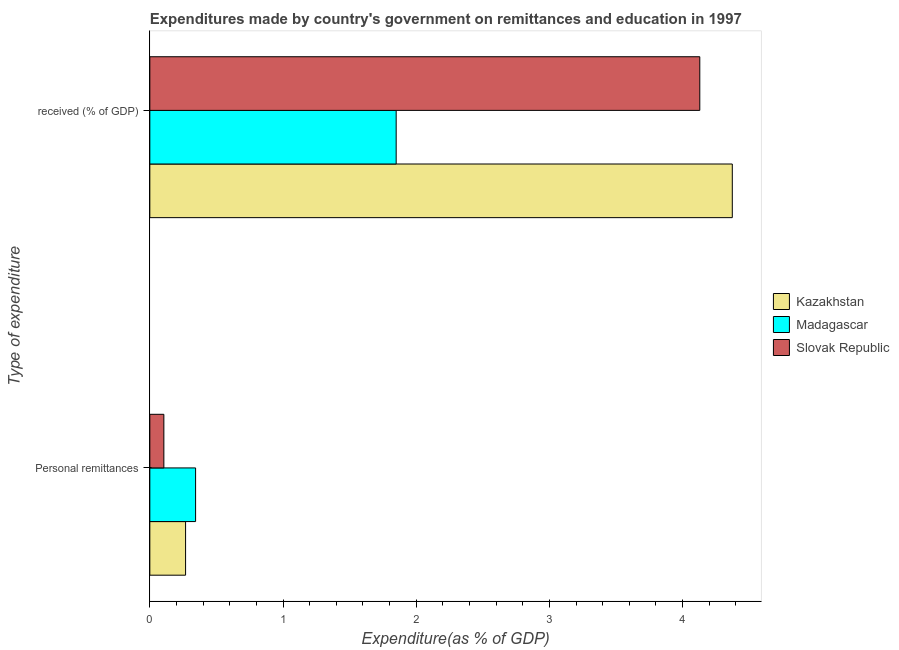How many different coloured bars are there?
Your answer should be very brief. 3. How many groups of bars are there?
Your answer should be compact. 2. Are the number of bars on each tick of the Y-axis equal?
Provide a succinct answer. Yes. How many bars are there on the 1st tick from the bottom?
Offer a very short reply. 3. What is the label of the 2nd group of bars from the top?
Offer a terse response. Personal remittances. What is the expenditure in education in Madagascar?
Ensure brevity in your answer.  1.85. Across all countries, what is the maximum expenditure in personal remittances?
Keep it short and to the point. 0.34. Across all countries, what is the minimum expenditure in education?
Ensure brevity in your answer.  1.85. In which country was the expenditure in education maximum?
Give a very brief answer. Kazakhstan. In which country was the expenditure in education minimum?
Ensure brevity in your answer.  Madagascar. What is the total expenditure in personal remittances in the graph?
Keep it short and to the point. 0.72. What is the difference between the expenditure in personal remittances in Slovak Republic and that in Madagascar?
Make the answer very short. -0.24. What is the difference between the expenditure in education in Slovak Republic and the expenditure in personal remittances in Kazakhstan?
Your answer should be compact. 3.86. What is the average expenditure in personal remittances per country?
Your response must be concise. 0.24. What is the difference between the expenditure in personal remittances and expenditure in education in Madagascar?
Provide a short and direct response. -1.51. What is the ratio of the expenditure in education in Kazakhstan to that in Madagascar?
Provide a succinct answer. 2.36. What does the 2nd bar from the top in  received (% of GDP) represents?
Make the answer very short. Madagascar. What does the 3rd bar from the bottom in Personal remittances represents?
Provide a succinct answer. Slovak Republic. How many bars are there?
Offer a terse response. 6. Are all the bars in the graph horizontal?
Keep it short and to the point. Yes. How many countries are there in the graph?
Provide a succinct answer. 3. What is the difference between two consecutive major ticks on the X-axis?
Make the answer very short. 1. Are the values on the major ticks of X-axis written in scientific E-notation?
Give a very brief answer. No. How many legend labels are there?
Provide a succinct answer. 3. What is the title of the graph?
Ensure brevity in your answer.  Expenditures made by country's government on remittances and education in 1997. Does "Sudan" appear as one of the legend labels in the graph?
Provide a short and direct response. No. What is the label or title of the X-axis?
Offer a very short reply. Expenditure(as % of GDP). What is the label or title of the Y-axis?
Make the answer very short. Type of expenditure. What is the Expenditure(as % of GDP) in Kazakhstan in Personal remittances?
Your response must be concise. 0.27. What is the Expenditure(as % of GDP) of Madagascar in Personal remittances?
Offer a terse response. 0.34. What is the Expenditure(as % of GDP) in Slovak Republic in Personal remittances?
Your answer should be very brief. 0.11. What is the Expenditure(as % of GDP) in Kazakhstan in  received (% of GDP)?
Ensure brevity in your answer.  4.37. What is the Expenditure(as % of GDP) in Madagascar in  received (% of GDP)?
Keep it short and to the point. 1.85. What is the Expenditure(as % of GDP) in Slovak Republic in  received (% of GDP)?
Offer a very short reply. 4.13. Across all Type of expenditure, what is the maximum Expenditure(as % of GDP) in Kazakhstan?
Your response must be concise. 4.37. Across all Type of expenditure, what is the maximum Expenditure(as % of GDP) in Madagascar?
Offer a very short reply. 1.85. Across all Type of expenditure, what is the maximum Expenditure(as % of GDP) of Slovak Republic?
Provide a short and direct response. 4.13. Across all Type of expenditure, what is the minimum Expenditure(as % of GDP) of Kazakhstan?
Your answer should be compact. 0.27. Across all Type of expenditure, what is the minimum Expenditure(as % of GDP) of Madagascar?
Provide a succinct answer. 0.34. Across all Type of expenditure, what is the minimum Expenditure(as % of GDP) in Slovak Republic?
Provide a succinct answer. 0.11. What is the total Expenditure(as % of GDP) in Kazakhstan in the graph?
Give a very brief answer. 4.64. What is the total Expenditure(as % of GDP) in Madagascar in the graph?
Your answer should be very brief. 2.19. What is the total Expenditure(as % of GDP) of Slovak Republic in the graph?
Keep it short and to the point. 4.23. What is the difference between the Expenditure(as % of GDP) of Kazakhstan in Personal remittances and that in  received (% of GDP)?
Make the answer very short. -4.11. What is the difference between the Expenditure(as % of GDP) in Madagascar in Personal remittances and that in  received (% of GDP)?
Provide a short and direct response. -1.51. What is the difference between the Expenditure(as % of GDP) of Slovak Republic in Personal remittances and that in  received (% of GDP)?
Keep it short and to the point. -4.02. What is the difference between the Expenditure(as % of GDP) in Kazakhstan in Personal remittances and the Expenditure(as % of GDP) in Madagascar in  received (% of GDP)?
Provide a succinct answer. -1.58. What is the difference between the Expenditure(as % of GDP) in Kazakhstan in Personal remittances and the Expenditure(as % of GDP) in Slovak Republic in  received (% of GDP)?
Provide a short and direct response. -3.86. What is the difference between the Expenditure(as % of GDP) of Madagascar in Personal remittances and the Expenditure(as % of GDP) of Slovak Republic in  received (% of GDP)?
Provide a succinct answer. -3.79. What is the average Expenditure(as % of GDP) of Kazakhstan per Type of expenditure?
Your answer should be very brief. 2.32. What is the average Expenditure(as % of GDP) in Madagascar per Type of expenditure?
Offer a very short reply. 1.1. What is the average Expenditure(as % of GDP) in Slovak Republic per Type of expenditure?
Give a very brief answer. 2.12. What is the difference between the Expenditure(as % of GDP) in Kazakhstan and Expenditure(as % of GDP) in Madagascar in Personal remittances?
Provide a short and direct response. -0.08. What is the difference between the Expenditure(as % of GDP) of Kazakhstan and Expenditure(as % of GDP) of Slovak Republic in Personal remittances?
Your answer should be very brief. 0.16. What is the difference between the Expenditure(as % of GDP) in Madagascar and Expenditure(as % of GDP) in Slovak Republic in Personal remittances?
Your response must be concise. 0.24. What is the difference between the Expenditure(as % of GDP) of Kazakhstan and Expenditure(as % of GDP) of Madagascar in  received (% of GDP)?
Your answer should be compact. 2.52. What is the difference between the Expenditure(as % of GDP) in Kazakhstan and Expenditure(as % of GDP) in Slovak Republic in  received (% of GDP)?
Your answer should be very brief. 0.24. What is the difference between the Expenditure(as % of GDP) of Madagascar and Expenditure(as % of GDP) of Slovak Republic in  received (% of GDP)?
Provide a short and direct response. -2.28. What is the ratio of the Expenditure(as % of GDP) in Kazakhstan in Personal remittances to that in  received (% of GDP)?
Ensure brevity in your answer.  0.06. What is the ratio of the Expenditure(as % of GDP) of Madagascar in Personal remittances to that in  received (% of GDP)?
Provide a short and direct response. 0.19. What is the ratio of the Expenditure(as % of GDP) of Slovak Republic in Personal remittances to that in  received (% of GDP)?
Offer a terse response. 0.03. What is the difference between the highest and the second highest Expenditure(as % of GDP) in Kazakhstan?
Your response must be concise. 4.11. What is the difference between the highest and the second highest Expenditure(as % of GDP) in Madagascar?
Keep it short and to the point. 1.51. What is the difference between the highest and the second highest Expenditure(as % of GDP) of Slovak Republic?
Provide a succinct answer. 4.02. What is the difference between the highest and the lowest Expenditure(as % of GDP) in Kazakhstan?
Keep it short and to the point. 4.11. What is the difference between the highest and the lowest Expenditure(as % of GDP) in Madagascar?
Your answer should be compact. 1.51. What is the difference between the highest and the lowest Expenditure(as % of GDP) of Slovak Republic?
Your answer should be very brief. 4.02. 